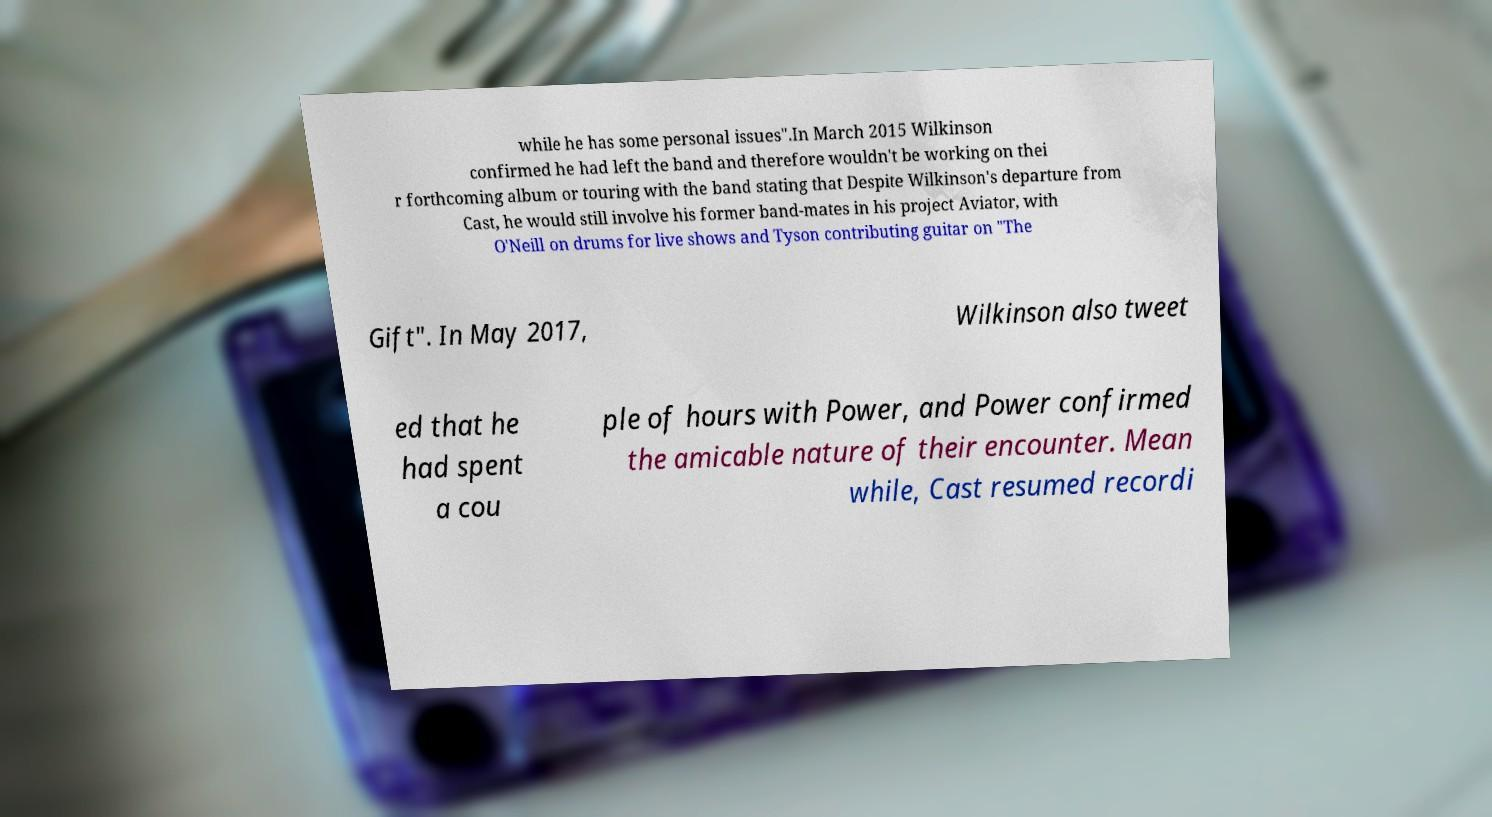Please identify and transcribe the text found in this image. while he has some personal issues".In March 2015 Wilkinson confirmed he had left the band and therefore wouldn't be working on thei r forthcoming album or touring with the band stating that Despite Wilkinson's departure from Cast, he would still involve his former band-mates in his project Aviator, with O'Neill on drums for live shows and Tyson contributing guitar on "The Gift". In May 2017, Wilkinson also tweet ed that he had spent a cou ple of hours with Power, and Power confirmed the amicable nature of their encounter. Mean while, Cast resumed recordi 